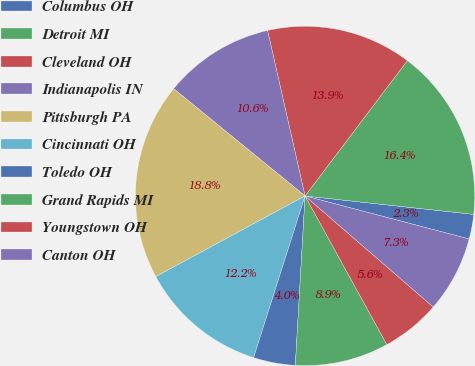<chart> <loc_0><loc_0><loc_500><loc_500><pie_chart><fcel>Columbus OH<fcel>Detroit MI<fcel>Cleveland OH<fcel>Indianapolis IN<fcel>Pittsburgh PA<fcel>Cincinnati OH<fcel>Toledo OH<fcel>Grand Rapids MI<fcel>Youngstown OH<fcel>Canton OH<nl><fcel>2.35%<fcel>16.43%<fcel>13.85%<fcel>10.56%<fcel>18.78%<fcel>12.21%<fcel>3.99%<fcel>8.92%<fcel>5.63%<fcel>7.28%<nl></chart> 